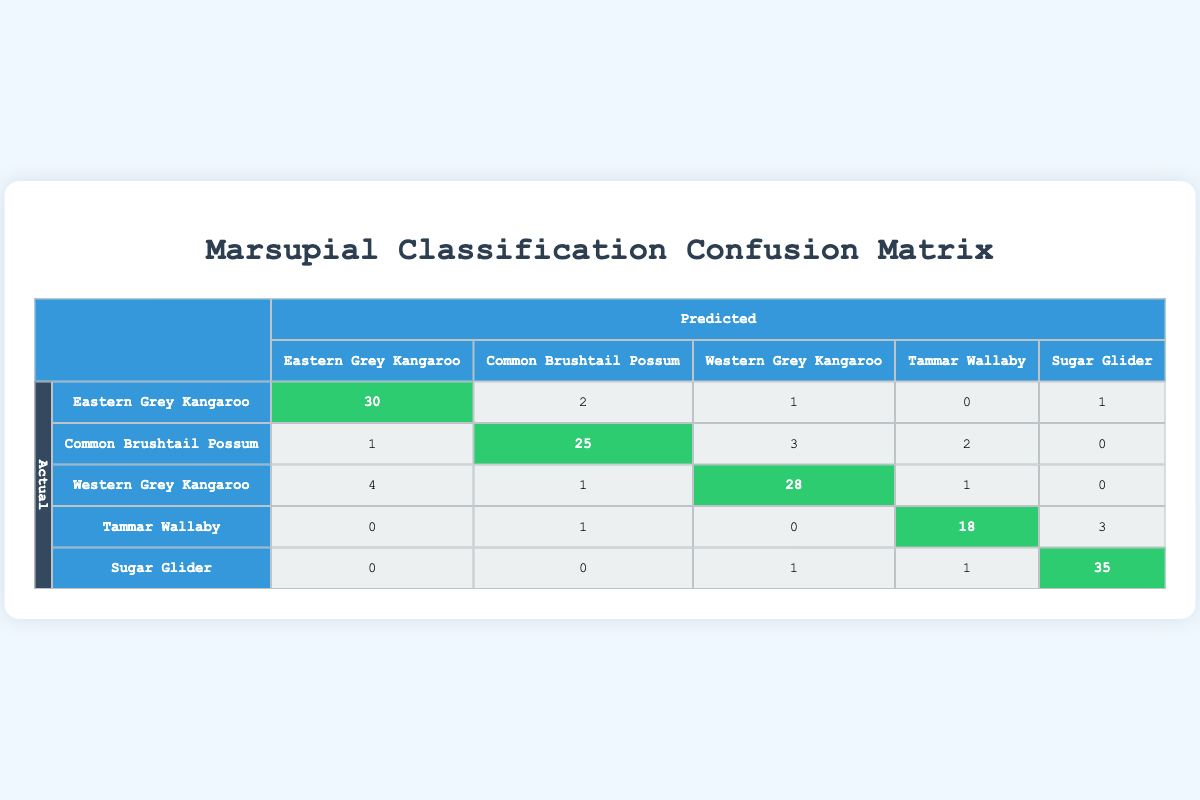What is the number of Eastern Grey Kangaroo instances correctly predicted? Observing the table, the entry for "Eastern Grey Kangaroo" under its own predicted label shows 30. This indicates the number of instances that were correctly classified.
Answer: 30 How many misunderstandings were there in predicting Common Brushtail Possum as Eastern Grey Kangaroo? In the row for "Common Brushtail Possum," the column for "Eastern Grey Kangaroo" indicates 1 instance. This signifies that one actual Common Brushtail Possum was mistakenly classified as Eastern Grey Kangaroo.
Answer: 1 What is the total number of predicted instances for Sugar Glider? To find the total, we sum all predictions in the row for "Sugar Glider": 0 (Eastern Grey Kangaroo) + 0 (Common Brushtail Possum) + 1 (Western Grey Kangaroo) + 1 (Tammar Wallaby) + 35 (Sugar Glider) = 37.
Answer: 37 Are there any Tammar Wallabies predicted as Western Grey Kangaroo? Looking at the Tammar Wallaby row, the column for Western Grey Kangaroo shows 0. This means that no instances of Tammar Wallaby were incorrectly predicted as Western Grey Kangaroo.
Answer: No What percentage of actual Tammar Wallabies were correctly classified? In the row for Tammar Wallaby, the correctly predicted instances are 18 (Tammar Wallaby column). The total number of actual Tammar Wallabies predicted can be calculated as: 18 + 0 + 1 + 3 = 22. Thus, the percentage is (18/22) * 100 = 81.82%.
Answer: 81.82% What is the total number of mistakes made in classifying Western Grey Kangaroo? In the row for "Western Grey Kangaroo," summing up the values in the non-diagonal cells gives us 4 + 1 + 3 + 1 = 9 mistakes. Non-diagonal values represent the misunderstandings between this and other species.
Answer: 9 How many times was the Common Brushtail Possum wrongly classified as Western Grey Kangaroo? The table shows that for the "Common Brushtail Possum" row, the column for "Western Grey Kangaroo" indicates 3. This means three instances of Common Brushtail Possum were incorrectly predicted as Western Grey Kangaroo.
Answer: 3 Out of all predictions for Eastern Grey Kangaroo, what was the correct classification rate? The total instances predicted for Eastern Grey Kangaroo are the sum of its row: 30 + 2 + 1 + 0 + 1 = 34. The correct classifications are 30; hence, the correct classification rate is (30/34) * 100 = 88.24%.
Answer: 88.24% 